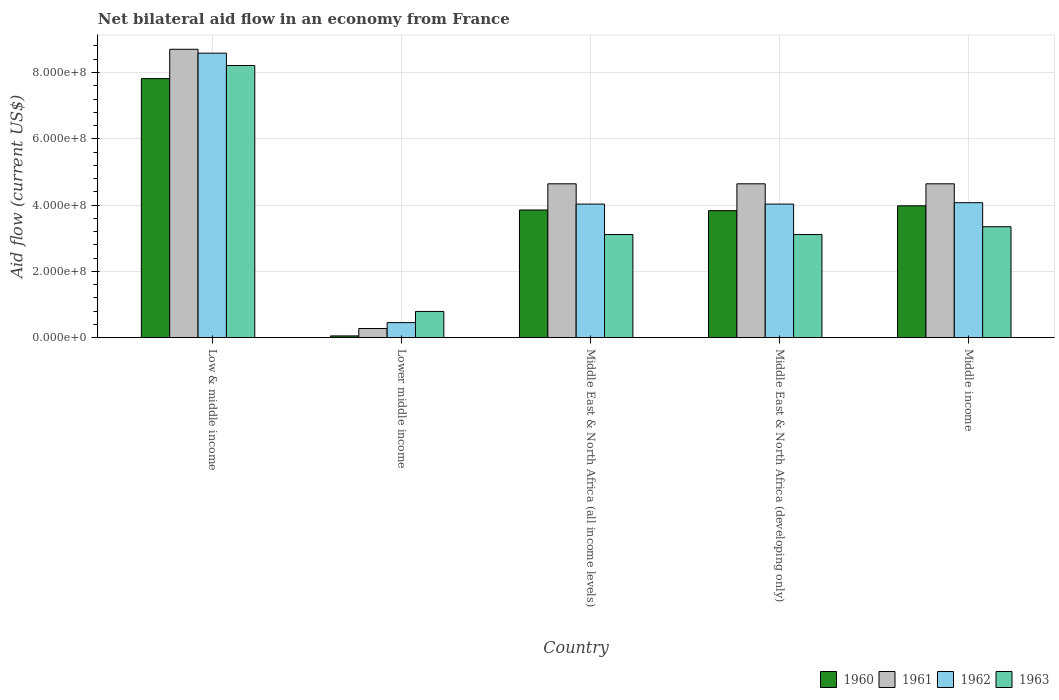How many different coloured bars are there?
Your response must be concise. 4. Are the number of bars on each tick of the X-axis equal?
Your response must be concise. Yes. What is the label of the 2nd group of bars from the left?
Provide a short and direct response. Lower middle income. What is the net bilateral aid flow in 1963 in Middle East & North Africa (developing only)?
Your answer should be compact. 3.11e+08. Across all countries, what is the maximum net bilateral aid flow in 1961?
Your answer should be compact. 8.70e+08. Across all countries, what is the minimum net bilateral aid flow in 1963?
Ensure brevity in your answer.  7.91e+07. In which country was the net bilateral aid flow in 1961 minimum?
Provide a succinct answer. Lower middle income. What is the total net bilateral aid flow in 1963 in the graph?
Your answer should be very brief. 1.86e+09. What is the difference between the net bilateral aid flow in 1963 in Low & middle income and that in Middle East & North Africa (all income levels)?
Provide a short and direct response. 5.10e+08. What is the difference between the net bilateral aid flow in 1961 in Middle East & North Africa (all income levels) and the net bilateral aid flow in 1962 in Low & middle income?
Offer a terse response. -3.94e+08. What is the average net bilateral aid flow in 1963 per country?
Keep it short and to the point. 3.71e+08. What is the difference between the net bilateral aid flow of/in 1962 and net bilateral aid flow of/in 1960 in Middle East & North Africa (all income levels)?
Your answer should be compact. 1.78e+07. In how many countries, is the net bilateral aid flow in 1961 greater than 40000000 US$?
Give a very brief answer. 4. What is the ratio of the net bilateral aid flow in 1960 in Low & middle income to that in Middle East & North Africa (all income levels)?
Make the answer very short. 2.03. Is the net bilateral aid flow in 1961 in Lower middle income less than that in Middle East & North Africa (developing only)?
Your answer should be compact. Yes. Is the difference between the net bilateral aid flow in 1962 in Middle East & North Africa (all income levels) and Middle East & North Africa (developing only) greater than the difference between the net bilateral aid flow in 1960 in Middle East & North Africa (all income levels) and Middle East & North Africa (developing only)?
Your answer should be compact. No. What is the difference between the highest and the second highest net bilateral aid flow in 1961?
Provide a short and direct response. 4.06e+08. What is the difference between the highest and the lowest net bilateral aid flow in 1963?
Your response must be concise. 7.42e+08. Is it the case that in every country, the sum of the net bilateral aid flow in 1963 and net bilateral aid flow in 1960 is greater than the sum of net bilateral aid flow in 1962 and net bilateral aid flow in 1961?
Give a very brief answer. No. What does the 1st bar from the left in Middle East & North Africa (developing only) represents?
Give a very brief answer. 1960. What does the 4th bar from the right in Lower middle income represents?
Keep it short and to the point. 1960. Is it the case that in every country, the sum of the net bilateral aid flow in 1961 and net bilateral aid flow in 1962 is greater than the net bilateral aid flow in 1963?
Offer a very short reply. No. Are all the bars in the graph horizontal?
Provide a succinct answer. No. What is the difference between two consecutive major ticks on the Y-axis?
Make the answer very short. 2.00e+08. Are the values on the major ticks of Y-axis written in scientific E-notation?
Offer a very short reply. Yes. Does the graph contain grids?
Your answer should be very brief. Yes. How many legend labels are there?
Offer a very short reply. 4. What is the title of the graph?
Offer a very short reply. Net bilateral aid flow in an economy from France. Does "1972" appear as one of the legend labels in the graph?
Provide a short and direct response. No. What is the label or title of the Y-axis?
Provide a short and direct response. Aid flow (current US$). What is the Aid flow (current US$) of 1960 in Low & middle income?
Offer a terse response. 7.82e+08. What is the Aid flow (current US$) in 1961 in Low & middle income?
Offer a terse response. 8.70e+08. What is the Aid flow (current US$) of 1962 in Low & middle income?
Keep it short and to the point. 8.58e+08. What is the Aid flow (current US$) in 1963 in Low & middle income?
Offer a very short reply. 8.21e+08. What is the Aid flow (current US$) in 1960 in Lower middle income?
Keep it short and to the point. 5.30e+06. What is the Aid flow (current US$) of 1961 in Lower middle income?
Offer a very short reply. 2.76e+07. What is the Aid flow (current US$) in 1962 in Lower middle income?
Keep it short and to the point. 4.54e+07. What is the Aid flow (current US$) of 1963 in Lower middle income?
Provide a succinct answer. 7.91e+07. What is the Aid flow (current US$) of 1960 in Middle East & North Africa (all income levels)?
Your answer should be very brief. 3.85e+08. What is the Aid flow (current US$) in 1961 in Middle East & North Africa (all income levels)?
Make the answer very short. 4.64e+08. What is the Aid flow (current US$) of 1962 in Middle East & North Africa (all income levels)?
Your response must be concise. 4.03e+08. What is the Aid flow (current US$) of 1963 in Middle East & North Africa (all income levels)?
Keep it short and to the point. 3.11e+08. What is the Aid flow (current US$) of 1960 in Middle East & North Africa (developing only)?
Provide a short and direct response. 3.83e+08. What is the Aid flow (current US$) of 1961 in Middle East & North Africa (developing only)?
Keep it short and to the point. 4.64e+08. What is the Aid flow (current US$) of 1962 in Middle East & North Africa (developing only)?
Provide a short and direct response. 4.03e+08. What is the Aid flow (current US$) of 1963 in Middle East & North Africa (developing only)?
Offer a terse response. 3.11e+08. What is the Aid flow (current US$) of 1960 in Middle income?
Offer a very short reply. 3.98e+08. What is the Aid flow (current US$) of 1961 in Middle income?
Your answer should be very brief. 4.64e+08. What is the Aid flow (current US$) in 1962 in Middle income?
Make the answer very short. 4.07e+08. What is the Aid flow (current US$) of 1963 in Middle income?
Offer a very short reply. 3.35e+08. Across all countries, what is the maximum Aid flow (current US$) in 1960?
Ensure brevity in your answer.  7.82e+08. Across all countries, what is the maximum Aid flow (current US$) in 1961?
Make the answer very short. 8.70e+08. Across all countries, what is the maximum Aid flow (current US$) in 1962?
Offer a very short reply. 8.58e+08. Across all countries, what is the maximum Aid flow (current US$) in 1963?
Offer a very short reply. 8.21e+08. Across all countries, what is the minimum Aid flow (current US$) of 1960?
Offer a terse response. 5.30e+06. Across all countries, what is the minimum Aid flow (current US$) in 1961?
Your answer should be compact. 2.76e+07. Across all countries, what is the minimum Aid flow (current US$) of 1962?
Offer a very short reply. 4.54e+07. Across all countries, what is the minimum Aid flow (current US$) of 1963?
Your answer should be compact. 7.91e+07. What is the total Aid flow (current US$) in 1960 in the graph?
Offer a terse response. 1.95e+09. What is the total Aid flow (current US$) in 1961 in the graph?
Provide a succinct answer. 2.29e+09. What is the total Aid flow (current US$) of 1962 in the graph?
Offer a terse response. 2.12e+09. What is the total Aid flow (current US$) in 1963 in the graph?
Your answer should be very brief. 1.86e+09. What is the difference between the Aid flow (current US$) in 1960 in Low & middle income and that in Lower middle income?
Your response must be concise. 7.76e+08. What is the difference between the Aid flow (current US$) in 1961 in Low & middle income and that in Lower middle income?
Your response must be concise. 8.42e+08. What is the difference between the Aid flow (current US$) in 1962 in Low & middle income and that in Lower middle income?
Your answer should be very brief. 8.13e+08. What is the difference between the Aid flow (current US$) in 1963 in Low & middle income and that in Lower middle income?
Ensure brevity in your answer.  7.42e+08. What is the difference between the Aid flow (current US$) of 1960 in Low & middle income and that in Middle East & North Africa (all income levels)?
Your answer should be compact. 3.96e+08. What is the difference between the Aid flow (current US$) in 1961 in Low & middle income and that in Middle East & North Africa (all income levels)?
Offer a very short reply. 4.06e+08. What is the difference between the Aid flow (current US$) in 1962 in Low & middle income and that in Middle East & North Africa (all income levels)?
Your response must be concise. 4.55e+08. What is the difference between the Aid flow (current US$) in 1963 in Low & middle income and that in Middle East & North Africa (all income levels)?
Your answer should be very brief. 5.10e+08. What is the difference between the Aid flow (current US$) in 1960 in Low & middle income and that in Middle East & North Africa (developing only)?
Your answer should be very brief. 3.98e+08. What is the difference between the Aid flow (current US$) of 1961 in Low & middle income and that in Middle East & North Africa (developing only)?
Offer a terse response. 4.06e+08. What is the difference between the Aid flow (current US$) of 1962 in Low & middle income and that in Middle East & North Africa (developing only)?
Give a very brief answer. 4.55e+08. What is the difference between the Aid flow (current US$) in 1963 in Low & middle income and that in Middle East & North Africa (developing only)?
Keep it short and to the point. 5.10e+08. What is the difference between the Aid flow (current US$) of 1960 in Low & middle income and that in Middle income?
Give a very brief answer. 3.84e+08. What is the difference between the Aid flow (current US$) in 1961 in Low & middle income and that in Middle income?
Offer a terse response. 4.06e+08. What is the difference between the Aid flow (current US$) in 1962 in Low & middle income and that in Middle income?
Keep it short and to the point. 4.51e+08. What is the difference between the Aid flow (current US$) in 1963 in Low & middle income and that in Middle income?
Your answer should be compact. 4.86e+08. What is the difference between the Aid flow (current US$) in 1960 in Lower middle income and that in Middle East & North Africa (all income levels)?
Keep it short and to the point. -3.80e+08. What is the difference between the Aid flow (current US$) in 1961 in Lower middle income and that in Middle East & North Africa (all income levels)?
Offer a terse response. -4.37e+08. What is the difference between the Aid flow (current US$) in 1962 in Lower middle income and that in Middle East & North Africa (all income levels)?
Your response must be concise. -3.58e+08. What is the difference between the Aid flow (current US$) of 1963 in Lower middle income and that in Middle East & North Africa (all income levels)?
Your response must be concise. -2.32e+08. What is the difference between the Aid flow (current US$) of 1960 in Lower middle income and that in Middle East & North Africa (developing only)?
Ensure brevity in your answer.  -3.78e+08. What is the difference between the Aid flow (current US$) of 1961 in Lower middle income and that in Middle East & North Africa (developing only)?
Keep it short and to the point. -4.37e+08. What is the difference between the Aid flow (current US$) of 1962 in Lower middle income and that in Middle East & North Africa (developing only)?
Make the answer very short. -3.58e+08. What is the difference between the Aid flow (current US$) of 1963 in Lower middle income and that in Middle East & North Africa (developing only)?
Make the answer very short. -2.32e+08. What is the difference between the Aid flow (current US$) in 1960 in Lower middle income and that in Middle income?
Offer a terse response. -3.92e+08. What is the difference between the Aid flow (current US$) of 1961 in Lower middle income and that in Middle income?
Ensure brevity in your answer.  -4.37e+08. What is the difference between the Aid flow (current US$) in 1962 in Lower middle income and that in Middle income?
Ensure brevity in your answer.  -3.62e+08. What is the difference between the Aid flow (current US$) in 1963 in Lower middle income and that in Middle income?
Give a very brief answer. -2.56e+08. What is the difference between the Aid flow (current US$) in 1961 in Middle East & North Africa (all income levels) and that in Middle East & North Africa (developing only)?
Your answer should be compact. 0. What is the difference between the Aid flow (current US$) of 1962 in Middle East & North Africa (all income levels) and that in Middle East & North Africa (developing only)?
Your response must be concise. 0. What is the difference between the Aid flow (current US$) of 1960 in Middle East & North Africa (all income levels) and that in Middle income?
Provide a short and direct response. -1.26e+07. What is the difference between the Aid flow (current US$) in 1961 in Middle East & North Africa (all income levels) and that in Middle income?
Provide a succinct answer. 0. What is the difference between the Aid flow (current US$) in 1962 in Middle East & North Africa (all income levels) and that in Middle income?
Your answer should be very brief. -4.20e+06. What is the difference between the Aid flow (current US$) in 1963 in Middle East & North Africa (all income levels) and that in Middle income?
Give a very brief answer. -2.36e+07. What is the difference between the Aid flow (current US$) of 1960 in Middle East & North Africa (developing only) and that in Middle income?
Provide a short and direct response. -1.46e+07. What is the difference between the Aid flow (current US$) in 1962 in Middle East & North Africa (developing only) and that in Middle income?
Offer a terse response. -4.20e+06. What is the difference between the Aid flow (current US$) in 1963 in Middle East & North Africa (developing only) and that in Middle income?
Ensure brevity in your answer.  -2.36e+07. What is the difference between the Aid flow (current US$) of 1960 in Low & middle income and the Aid flow (current US$) of 1961 in Lower middle income?
Offer a terse response. 7.54e+08. What is the difference between the Aid flow (current US$) of 1960 in Low & middle income and the Aid flow (current US$) of 1962 in Lower middle income?
Provide a succinct answer. 7.36e+08. What is the difference between the Aid flow (current US$) of 1960 in Low & middle income and the Aid flow (current US$) of 1963 in Lower middle income?
Your response must be concise. 7.02e+08. What is the difference between the Aid flow (current US$) in 1961 in Low & middle income and the Aid flow (current US$) in 1962 in Lower middle income?
Provide a succinct answer. 8.25e+08. What is the difference between the Aid flow (current US$) in 1961 in Low & middle income and the Aid flow (current US$) in 1963 in Lower middle income?
Offer a terse response. 7.91e+08. What is the difference between the Aid flow (current US$) in 1962 in Low & middle income and the Aid flow (current US$) in 1963 in Lower middle income?
Give a very brief answer. 7.79e+08. What is the difference between the Aid flow (current US$) in 1960 in Low & middle income and the Aid flow (current US$) in 1961 in Middle East & North Africa (all income levels)?
Provide a succinct answer. 3.17e+08. What is the difference between the Aid flow (current US$) in 1960 in Low & middle income and the Aid flow (current US$) in 1962 in Middle East & North Africa (all income levels)?
Make the answer very short. 3.79e+08. What is the difference between the Aid flow (current US$) of 1960 in Low & middle income and the Aid flow (current US$) of 1963 in Middle East & North Africa (all income levels)?
Make the answer very short. 4.70e+08. What is the difference between the Aid flow (current US$) of 1961 in Low & middle income and the Aid flow (current US$) of 1962 in Middle East & North Africa (all income levels)?
Offer a terse response. 4.67e+08. What is the difference between the Aid flow (current US$) in 1961 in Low & middle income and the Aid flow (current US$) in 1963 in Middle East & North Africa (all income levels)?
Provide a short and direct response. 5.59e+08. What is the difference between the Aid flow (current US$) of 1962 in Low & middle income and the Aid flow (current US$) of 1963 in Middle East & North Africa (all income levels)?
Provide a short and direct response. 5.47e+08. What is the difference between the Aid flow (current US$) in 1960 in Low & middle income and the Aid flow (current US$) in 1961 in Middle East & North Africa (developing only)?
Provide a short and direct response. 3.17e+08. What is the difference between the Aid flow (current US$) in 1960 in Low & middle income and the Aid flow (current US$) in 1962 in Middle East & North Africa (developing only)?
Ensure brevity in your answer.  3.79e+08. What is the difference between the Aid flow (current US$) of 1960 in Low & middle income and the Aid flow (current US$) of 1963 in Middle East & North Africa (developing only)?
Your answer should be very brief. 4.70e+08. What is the difference between the Aid flow (current US$) of 1961 in Low & middle income and the Aid flow (current US$) of 1962 in Middle East & North Africa (developing only)?
Provide a short and direct response. 4.67e+08. What is the difference between the Aid flow (current US$) in 1961 in Low & middle income and the Aid flow (current US$) in 1963 in Middle East & North Africa (developing only)?
Your answer should be very brief. 5.59e+08. What is the difference between the Aid flow (current US$) in 1962 in Low & middle income and the Aid flow (current US$) in 1963 in Middle East & North Africa (developing only)?
Provide a short and direct response. 5.47e+08. What is the difference between the Aid flow (current US$) of 1960 in Low & middle income and the Aid flow (current US$) of 1961 in Middle income?
Offer a terse response. 3.17e+08. What is the difference between the Aid flow (current US$) of 1960 in Low & middle income and the Aid flow (current US$) of 1962 in Middle income?
Offer a very short reply. 3.74e+08. What is the difference between the Aid flow (current US$) in 1960 in Low & middle income and the Aid flow (current US$) in 1963 in Middle income?
Make the answer very short. 4.47e+08. What is the difference between the Aid flow (current US$) in 1961 in Low & middle income and the Aid flow (current US$) in 1962 in Middle income?
Ensure brevity in your answer.  4.63e+08. What is the difference between the Aid flow (current US$) in 1961 in Low & middle income and the Aid flow (current US$) in 1963 in Middle income?
Ensure brevity in your answer.  5.35e+08. What is the difference between the Aid flow (current US$) of 1962 in Low & middle income and the Aid flow (current US$) of 1963 in Middle income?
Your answer should be very brief. 5.24e+08. What is the difference between the Aid flow (current US$) in 1960 in Lower middle income and the Aid flow (current US$) in 1961 in Middle East & North Africa (all income levels)?
Your answer should be very brief. -4.59e+08. What is the difference between the Aid flow (current US$) in 1960 in Lower middle income and the Aid flow (current US$) in 1962 in Middle East & North Africa (all income levels)?
Provide a short and direct response. -3.98e+08. What is the difference between the Aid flow (current US$) of 1960 in Lower middle income and the Aid flow (current US$) of 1963 in Middle East & North Africa (all income levels)?
Provide a succinct answer. -3.06e+08. What is the difference between the Aid flow (current US$) in 1961 in Lower middle income and the Aid flow (current US$) in 1962 in Middle East & North Africa (all income levels)?
Offer a very short reply. -3.75e+08. What is the difference between the Aid flow (current US$) of 1961 in Lower middle income and the Aid flow (current US$) of 1963 in Middle East & North Africa (all income levels)?
Offer a very short reply. -2.84e+08. What is the difference between the Aid flow (current US$) of 1962 in Lower middle income and the Aid flow (current US$) of 1963 in Middle East & North Africa (all income levels)?
Give a very brief answer. -2.66e+08. What is the difference between the Aid flow (current US$) of 1960 in Lower middle income and the Aid flow (current US$) of 1961 in Middle East & North Africa (developing only)?
Provide a succinct answer. -4.59e+08. What is the difference between the Aid flow (current US$) of 1960 in Lower middle income and the Aid flow (current US$) of 1962 in Middle East & North Africa (developing only)?
Provide a short and direct response. -3.98e+08. What is the difference between the Aid flow (current US$) of 1960 in Lower middle income and the Aid flow (current US$) of 1963 in Middle East & North Africa (developing only)?
Your response must be concise. -3.06e+08. What is the difference between the Aid flow (current US$) in 1961 in Lower middle income and the Aid flow (current US$) in 1962 in Middle East & North Africa (developing only)?
Ensure brevity in your answer.  -3.75e+08. What is the difference between the Aid flow (current US$) of 1961 in Lower middle income and the Aid flow (current US$) of 1963 in Middle East & North Africa (developing only)?
Give a very brief answer. -2.84e+08. What is the difference between the Aid flow (current US$) in 1962 in Lower middle income and the Aid flow (current US$) in 1963 in Middle East & North Africa (developing only)?
Your response must be concise. -2.66e+08. What is the difference between the Aid flow (current US$) of 1960 in Lower middle income and the Aid flow (current US$) of 1961 in Middle income?
Give a very brief answer. -4.59e+08. What is the difference between the Aid flow (current US$) in 1960 in Lower middle income and the Aid flow (current US$) in 1962 in Middle income?
Provide a short and direct response. -4.02e+08. What is the difference between the Aid flow (current US$) of 1960 in Lower middle income and the Aid flow (current US$) of 1963 in Middle income?
Make the answer very short. -3.29e+08. What is the difference between the Aid flow (current US$) in 1961 in Lower middle income and the Aid flow (current US$) in 1962 in Middle income?
Provide a short and direct response. -3.80e+08. What is the difference between the Aid flow (current US$) of 1961 in Lower middle income and the Aid flow (current US$) of 1963 in Middle income?
Your answer should be compact. -3.07e+08. What is the difference between the Aid flow (current US$) in 1962 in Lower middle income and the Aid flow (current US$) in 1963 in Middle income?
Offer a very short reply. -2.89e+08. What is the difference between the Aid flow (current US$) in 1960 in Middle East & North Africa (all income levels) and the Aid flow (current US$) in 1961 in Middle East & North Africa (developing only)?
Make the answer very short. -7.90e+07. What is the difference between the Aid flow (current US$) of 1960 in Middle East & North Africa (all income levels) and the Aid flow (current US$) of 1962 in Middle East & North Africa (developing only)?
Make the answer very short. -1.78e+07. What is the difference between the Aid flow (current US$) of 1960 in Middle East & North Africa (all income levels) and the Aid flow (current US$) of 1963 in Middle East & North Africa (developing only)?
Ensure brevity in your answer.  7.41e+07. What is the difference between the Aid flow (current US$) in 1961 in Middle East & North Africa (all income levels) and the Aid flow (current US$) in 1962 in Middle East & North Africa (developing only)?
Keep it short and to the point. 6.12e+07. What is the difference between the Aid flow (current US$) of 1961 in Middle East & North Africa (all income levels) and the Aid flow (current US$) of 1963 in Middle East & North Africa (developing only)?
Offer a very short reply. 1.53e+08. What is the difference between the Aid flow (current US$) in 1962 in Middle East & North Africa (all income levels) and the Aid flow (current US$) in 1963 in Middle East & North Africa (developing only)?
Provide a succinct answer. 9.19e+07. What is the difference between the Aid flow (current US$) of 1960 in Middle East & North Africa (all income levels) and the Aid flow (current US$) of 1961 in Middle income?
Your answer should be compact. -7.90e+07. What is the difference between the Aid flow (current US$) of 1960 in Middle East & North Africa (all income levels) and the Aid flow (current US$) of 1962 in Middle income?
Give a very brief answer. -2.20e+07. What is the difference between the Aid flow (current US$) in 1960 in Middle East & North Africa (all income levels) and the Aid flow (current US$) in 1963 in Middle income?
Your response must be concise. 5.05e+07. What is the difference between the Aid flow (current US$) in 1961 in Middle East & North Africa (all income levels) and the Aid flow (current US$) in 1962 in Middle income?
Offer a terse response. 5.70e+07. What is the difference between the Aid flow (current US$) of 1961 in Middle East & North Africa (all income levels) and the Aid flow (current US$) of 1963 in Middle income?
Ensure brevity in your answer.  1.30e+08. What is the difference between the Aid flow (current US$) in 1962 in Middle East & North Africa (all income levels) and the Aid flow (current US$) in 1963 in Middle income?
Give a very brief answer. 6.83e+07. What is the difference between the Aid flow (current US$) in 1960 in Middle East & North Africa (developing only) and the Aid flow (current US$) in 1961 in Middle income?
Provide a succinct answer. -8.10e+07. What is the difference between the Aid flow (current US$) in 1960 in Middle East & North Africa (developing only) and the Aid flow (current US$) in 1962 in Middle income?
Provide a succinct answer. -2.40e+07. What is the difference between the Aid flow (current US$) in 1960 in Middle East & North Africa (developing only) and the Aid flow (current US$) in 1963 in Middle income?
Your response must be concise. 4.85e+07. What is the difference between the Aid flow (current US$) in 1961 in Middle East & North Africa (developing only) and the Aid flow (current US$) in 1962 in Middle income?
Ensure brevity in your answer.  5.70e+07. What is the difference between the Aid flow (current US$) of 1961 in Middle East & North Africa (developing only) and the Aid flow (current US$) of 1963 in Middle income?
Offer a very short reply. 1.30e+08. What is the difference between the Aid flow (current US$) of 1962 in Middle East & North Africa (developing only) and the Aid flow (current US$) of 1963 in Middle income?
Your response must be concise. 6.83e+07. What is the average Aid flow (current US$) in 1960 per country?
Make the answer very short. 3.91e+08. What is the average Aid flow (current US$) in 1961 per country?
Your answer should be very brief. 4.58e+08. What is the average Aid flow (current US$) of 1962 per country?
Your answer should be compact. 4.23e+08. What is the average Aid flow (current US$) in 1963 per country?
Offer a terse response. 3.71e+08. What is the difference between the Aid flow (current US$) of 1960 and Aid flow (current US$) of 1961 in Low & middle income?
Provide a short and direct response. -8.84e+07. What is the difference between the Aid flow (current US$) of 1960 and Aid flow (current US$) of 1962 in Low & middle income?
Give a very brief answer. -7.67e+07. What is the difference between the Aid flow (current US$) of 1960 and Aid flow (current US$) of 1963 in Low & middle income?
Your response must be concise. -3.95e+07. What is the difference between the Aid flow (current US$) in 1961 and Aid flow (current US$) in 1962 in Low & middle income?
Provide a short and direct response. 1.17e+07. What is the difference between the Aid flow (current US$) in 1961 and Aid flow (current US$) in 1963 in Low & middle income?
Your response must be concise. 4.89e+07. What is the difference between the Aid flow (current US$) in 1962 and Aid flow (current US$) in 1963 in Low & middle income?
Your response must be concise. 3.72e+07. What is the difference between the Aid flow (current US$) of 1960 and Aid flow (current US$) of 1961 in Lower middle income?
Your response must be concise. -2.23e+07. What is the difference between the Aid flow (current US$) of 1960 and Aid flow (current US$) of 1962 in Lower middle income?
Give a very brief answer. -4.01e+07. What is the difference between the Aid flow (current US$) of 1960 and Aid flow (current US$) of 1963 in Lower middle income?
Ensure brevity in your answer.  -7.38e+07. What is the difference between the Aid flow (current US$) of 1961 and Aid flow (current US$) of 1962 in Lower middle income?
Your answer should be compact. -1.78e+07. What is the difference between the Aid flow (current US$) in 1961 and Aid flow (current US$) in 1963 in Lower middle income?
Your answer should be compact. -5.15e+07. What is the difference between the Aid flow (current US$) of 1962 and Aid flow (current US$) of 1963 in Lower middle income?
Your answer should be compact. -3.37e+07. What is the difference between the Aid flow (current US$) of 1960 and Aid flow (current US$) of 1961 in Middle East & North Africa (all income levels)?
Provide a succinct answer. -7.90e+07. What is the difference between the Aid flow (current US$) of 1960 and Aid flow (current US$) of 1962 in Middle East & North Africa (all income levels)?
Offer a terse response. -1.78e+07. What is the difference between the Aid flow (current US$) in 1960 and Aid flow (current US$) in 1963 in Middle East & North Africa (all income levels)?
Offer a very short reply. 7.41e+07. What is the difference between the Aid flow (current US$) of 1961 and Aid flow (current US$) of 1962 in Middle East & North Africa (all income levels)?
Your answer should be very brief. 6.12e+07. What is the difference between the Aid flow (current US$) of 1961 and Aid flow (current US$) of 1963 in Middle East & North Africa (all income levels)?
Offer a very short reply. 1.53e+08. What is the difference between the Aid flow (current US$) in 1962 and Aid flow (current US$) in 1963 in Middle East & North Africa (all income levels)?
Keep it short and to the point. 9.19e+07. What is the difference between the Aid flow (current US$) in 1960 and Aid flow (current US$) in 1961 in Middle East & North Africa (developing only)?
Your response must be concise. -8.10e+07. What is the difference between the Aid flow (current US$) in 1960 and Aid flow (current US$) in 1962 in Middle East & North Africa (developing only)?
Your answer should be very brief. -1.98e+07. What is the difference between the Aid flow (current US$) of 1960 and Aid flow (current US$) of 1963 in Middle East & North Africa (developing only)?
Offer a very short reply. 7.21e+07. What is the difference between the Aid flow (current US$) of 1961 and Aid flow (current US$) of 1962 in Middle East & North Africa (developing only)?
Offer a very short reply. 6.12e+07. What is the difference between the Aid flow (current US$) in 1961 and Aid flow (current US$) in 1963 in Middle East & North Africa (developing only)?
Provide a succinct answer. 1.53e+08. What is the difference between the Aid flow (current US$) in 1962 and Aid flow (current US$) in 1963 in Middle East & North Africa (developing only)?
Provide a short and direct response. 9.19e+07. What is the difference between the Aid flow (current US$) of 1960 and Aid flow (current US$) of 1961 in Middle income?
Your response must be concise. -6.64e+07. What is the difference between the Aid flow (current US$) of 1960 and Aid flow (current US$) of 1962 in Middle income?
Provide a short and direct response. -9.40e+06. What is the difference between the Aid flow (current US$) in 1960 and Aid flow (current US$) in 1963 in Middle income?
Your answer should be compact. 6.31e+07. What is the difference between the Aid flow (current US$) of 1961 and Aid flow (current US$) of 1962 in Middle income?
Make the answer very short. 5.70e+07. What is the difference between the Aid flow (current US$) in 1961 and Aid flow (current US$) in 1963 in Middle income?
Offer a terse response. 1.30e+08. What is the difference between the Aid flow (current US$) of 1962 and Aid flow (current US$) of 1963 in Middle income?
Your answer should be very brief. 7.25e+07. What is the ratio of the Aid flow (current US$) of 1960 in Low & middle income to that in Lower middle income?
Your response must be concise. 147.47. What is the ratio of the Aid flow (current US$) of 1961 in Low & middle income to that in Lower middle income?
Provide a succinct answer. 31.52. What is the ratio of the Aid flow (current US$) of 1962 in Low & middle income to that in Lower middle income?
Provide a succinct answer. 18.91. What is the ratio of the Aid flow (current US$) in 1963 in Low & middle income to that in Lower middle income?
Make the answer very short. 10.38. What is the ratio of the Aid flow (current US$) in 1960 in Low & middle income to that in Middle East & North Africa (all income levels)?
Your answer should be very brief. 2.03. What is the ratio of the Aid flow (current US$) in 1961 in Low & middle income to that in Middle East & North Africa (all income levels)?
Give a very brief answer. 1.87. What is the ratio of the Aid flow (current US$) of 1962 in Low & middle income to that in Middle East & North Africa (all income levels)?
Give a very brief answer. 2.13. What is the ratio of the Aid flow (current US$) in 1963 in Low & middle income to that in Middle East & North Africa (all income levels)?
Keep it short and to the point. 2.64. What is the ratio of the Aid flow (current US$) of 1960 in Low & middle income to that in Middle East & North Africa (developing only)?
Your answer should be compact. 2.04. What is the ratio of the Aid flow (current US$) in 1961 in Low & middle income to that in Middle East & North Africa (developing only)?
Your answer should be compact. 1.87. What is the ratio of the Aid flow (current US$) of 1962 in Low & middle income to that in Middle East & North Africa (developing only)?
Give a very brief answer. 2.13. What is the ratio of the Aid flow (current US$) in 1963 in Low & middle income to that in Middle East & North Africa (developing only)?
Ensure brevity in your answer.  2.64. What is the ratio of the Aid flow (current US$) of 1960 in Low & middle income to that in Middle income?
Your answer should be compact. 1.96. What is the ratio of the Aid flow (current US$) of 1961 in Low & middle income to that in Middle income?
Make the answer very short. 1.87. What is the ratio of the Aid flow (current US$) in 1962 in Low & middle income to that in Middle income?
Your response must be concise. 2.11. What is the ratio of the Aid flow (current US$) in 1963 in Low & middle income to that in Middle income?
Your answer should be very brief. 2.45. What is the ratio of the Aid flow (current US$) in 1960 in Lower middle income to that in Middle East & North Africa (all income levels)?
Provide a succinct answer. 0.01. What is the ratio of the Aid flow (current US$) of 1961 in Lower middle income to that in Middle East & North Africa (all income levels)?
Your answer should be compact. 0.06. What is the ratio of the Aid flow (current US$) of 1962 in Lower middle income to that in Middle East & North Africa (all income levels)?
Give a very brief answer. 0.11. What is the ratio of the Aid flow (current US$) of 1963 in Lower middle income to that in Middle East & North Africa (all income levels)?
Provide a succinct answer. 0.25. What is the ratio of the Aid flow (current US$) of 1960 in Lower middle income to that in Middle East & North Africa (developing only)?
Provide a succinct answer. 0.01. What is the ratio of the Aid flow (current US$) in 1961 in Lower middle income to that in Middle East & North Africa (developing only)?
Keep it short and to the point. 0.06. What is the ratio of the Aid flow (current US$) in 1962 in Lower middle income to that in Middle East & North Africa (developing only)?
Your answer should be compact. 0.11. What is the ratio of the Aid flow (current US$) of 1963 in Lower middle income to that in Middle East & North Africa (developing only)?
Offer a very short reply. 0.25. What is the ratio of the Aid flow (current US$) in 1960 in Lower middle income to that in Middle income?
Provide a succinct answer. 0.01. What is the ratio of the Aid flow (current US$) in 1961 in Lower middle income to that in Middle income?
Offer a very short reply. 0.06. What is the ratio of the Aid flow (current US$) in 1962 in Lower middle income to that in Middle income?
Make the answer very short. 0.11. What is the ratio of the Aid flow (current US$) of 1963 in Lower middle income to that in Middle income?
Make the answer very short. 0.24. What is the ratio of the Aid flow (current US$) of 1963 in Middle East & North Africa (all income levels) to that in Middle East & North Africa (developing only)?
Make the answer very short. 1. What is the ratio of the Aid flow (current US$) of 1960 in Middle East & North Africa (all income levels) to that in Middle income?
Give a very brief answer. 0.97. What is the ratio of the Aid flow (current US$) in 1962 in Middle East & North Africa (all income levels) to that in Middle income?
Keep it short and to the point. 0.99. What is the ratio of the Aid flow (current US$) in 1963 in Middle East & North Africa (all income levels) to that in Middle income?
Your answer should be compact. 0.93. What is the ratio of the Aid flow (current US$) of 1960 in Middle East & North Africa (developing only) to that in Middle income?
Provide a succinct answer. 0.96. What is the ratio of the Aid flow (current US$) in 1961 in Middle East & North Africa (developing only) to that in Middle income?
Offer a terse response. 1. What is the ratio of the Aid flow (current US$) of 1962 in Middle East & North Africa (developing only) to that in Middle income?
Offer a very short reply. 0.99. What is the ratio of the Aid flow (current US$) in 1963 in Middle East & North Africa (developing only) to that in Middle income?
Provide a short and direct response. 0.93. What is the difference between the highest and the second highest Aid flow (current US$) of 1960?
Provide a succinct answer. 3.84e+08. What is the difference between the highest and the second highest Aid flow (current US$) of 1961?
Your answer should be very brief. 4.06e+08. What is the difference between the highest and the second highest Aid flow (current US$) in 1962?
Offer a very short reply. 4.51e+08. What is the difference between the highest and the second highest Aid flow (current US$) of 1963?
Your response must be concise. 4.86e+08. What is the difference between the highest and the lowest Aid flow (current US$) in 1960?
Provide a succinct answer. 7.76e+08. What is the difference between the highest and the lowest Aid flow (current US$) in 1961?
Ensure brevity in your answer.  8.42e+08. What is the difference between the highest and the lowest Aid flow (current US$) in 1962?
Make the answer very short. 8.13e+08. What is the difference between the highest and the lowest Aid flow (current US$) of 1963?
Keep it short and to the point. 7.42e+08. 